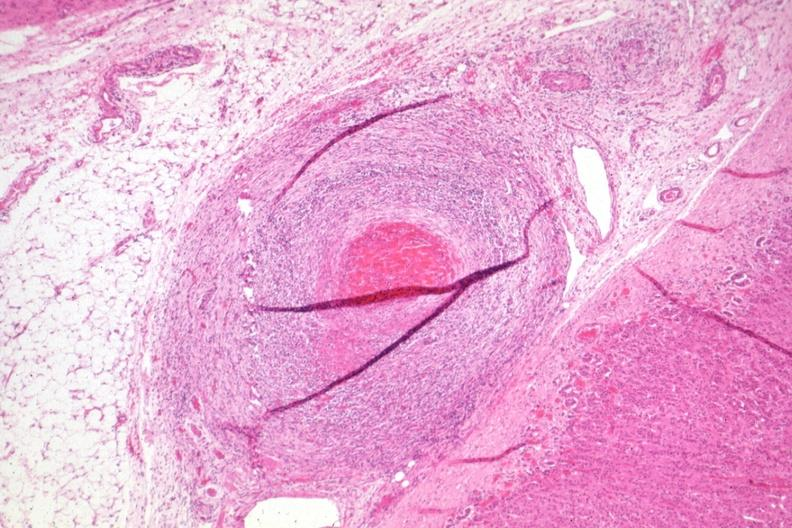what has folds?
Answer the question using a single word or phrase. Outside adrenal capsule section 